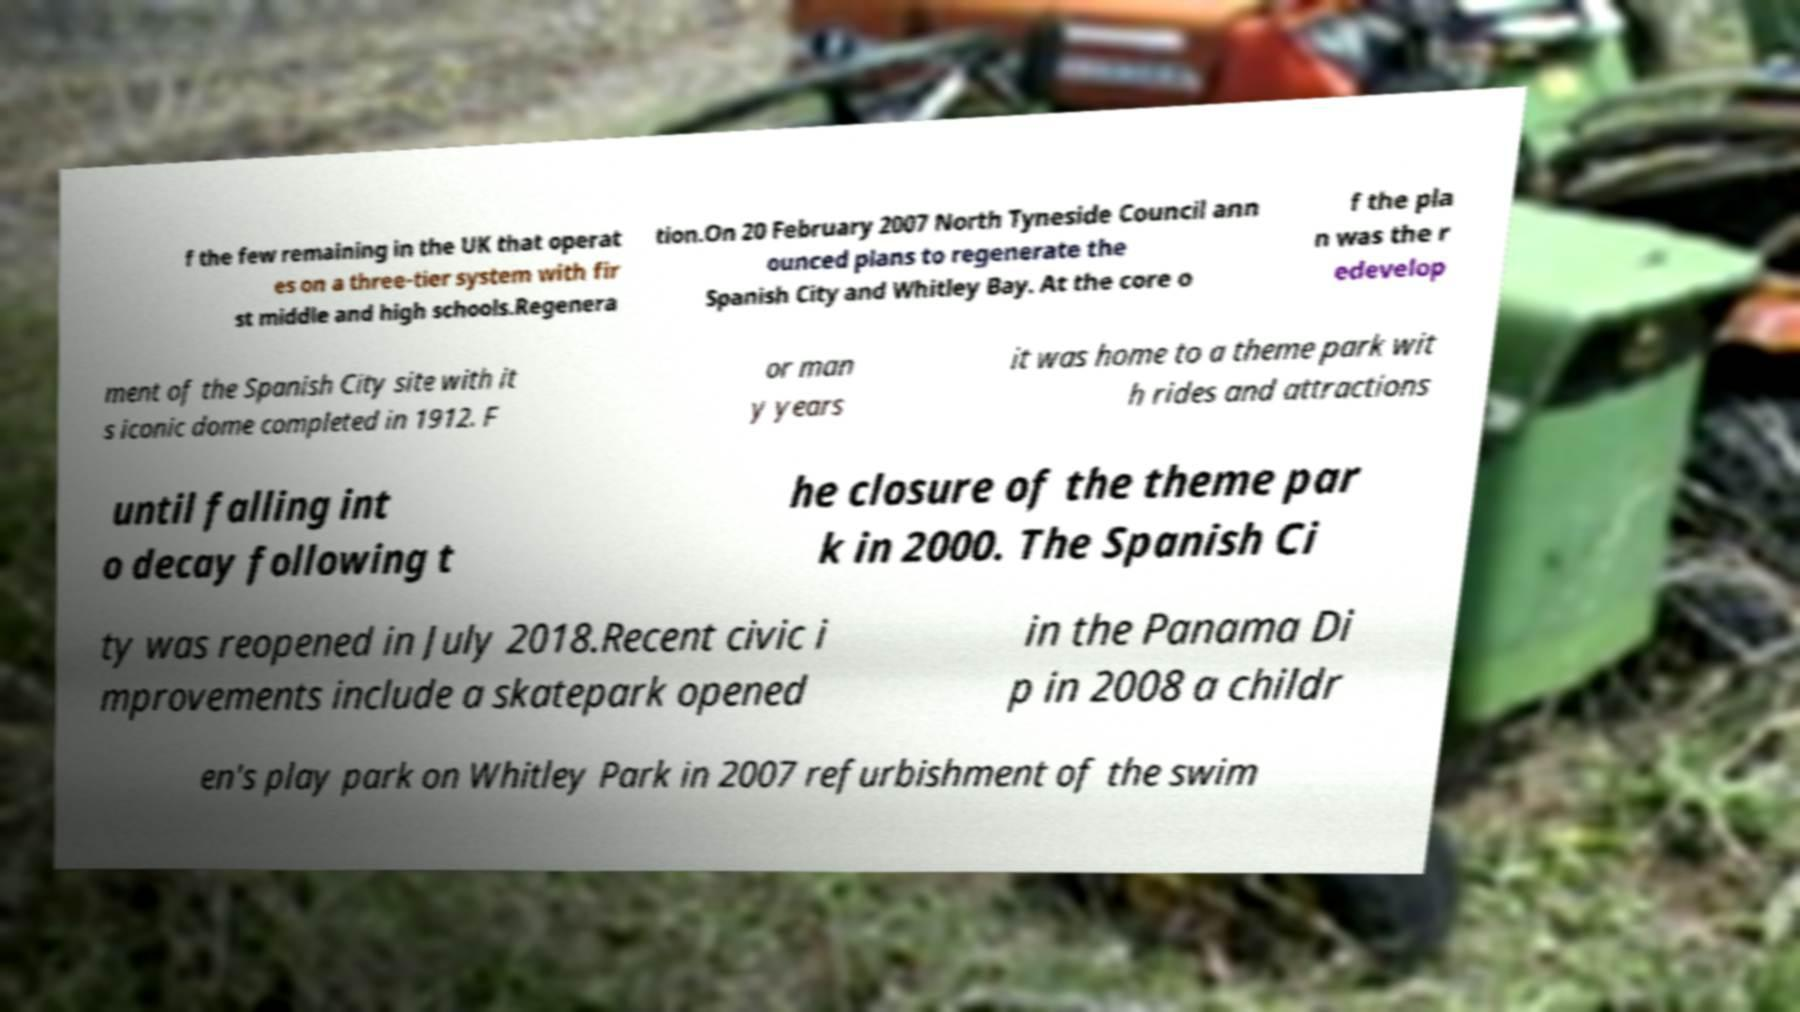Can you read and provide the text displayed in the image?This photo seems to have some interesting text. Can you extract and type it out for me? f the few remaining in the UK that operat es on a three-tier system with fir st middle and high schools.Regenera tion.On 20 February 2007 North Tyneside Council ann ounced plans to regenerate the Spanish City and Whitley Bay. At the core o f the pla n was the r edevelop ment of the Spanish City site with it s iconic dome completed in 1912. F or man y years it was home to a theme park wit h rides and attractions until falling int o decay following t he closure of the theme par k in 2000. The Spanish Ci ty was reopened in July 2018.Recent civic i mprovements include a skatepark opened in the Panama Di p in 2008 a childr en's play park on Whitley Park in 2007 refurbishment of the swim 